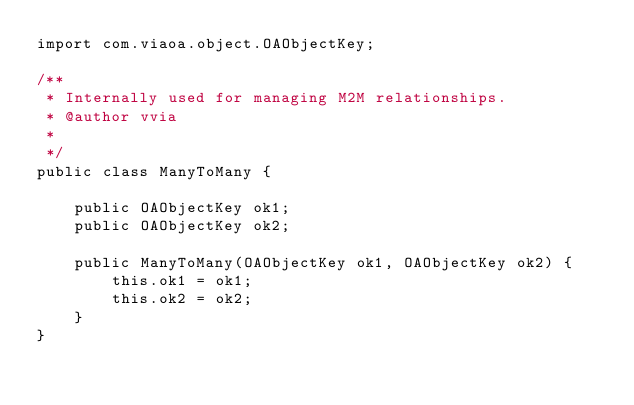Convert code to text. <code><loc_0><loc_0><loc_500><loc_500><_Java_>import com.viaoa.object.OAObjectKey;

/**
 * Internally used for managing M2M relationships.
 * @author vvia
 *
 */
public class ManyToMany {

    public OAObjectKey ok1;
    public OAObjectKey ok2;

    public ManyToMany(OAObjectKey ok1, OAObjectKey ok2) {
        this.ok1 = ok1;
        this.ok2 = ok2;
    }
}
</code> 